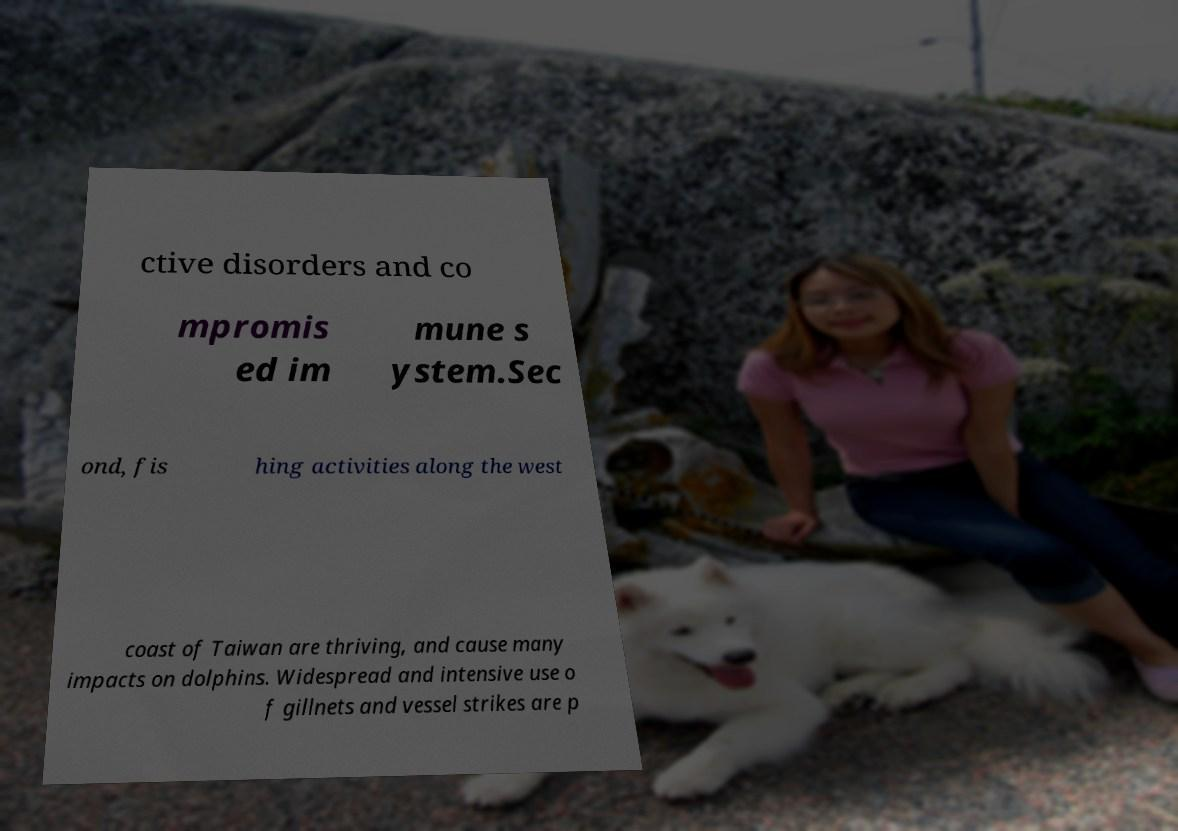For documentation purposes, I need the text within this image transcribed. Could you provide that? ctive disorders and co mpromis ed im mune s ystem.Sec ond, fis hing activities along the west coast of Taiwan are thriving, and cause many impacts on dolphins. Widespread and intensive use o f gillnets and vessel strikes are p 